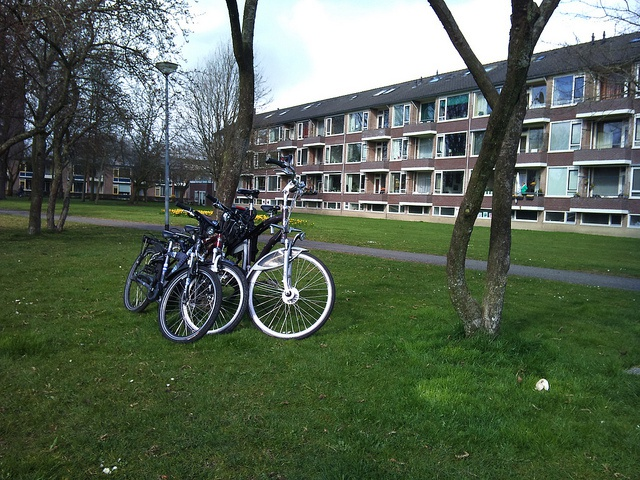Describe the objects in this image and their specific colors. I can see bicycle in black, white, gray, and darkgreen tones, bicycle in black and gray tones, and bicycle in black, gray, and white tones in this image. 